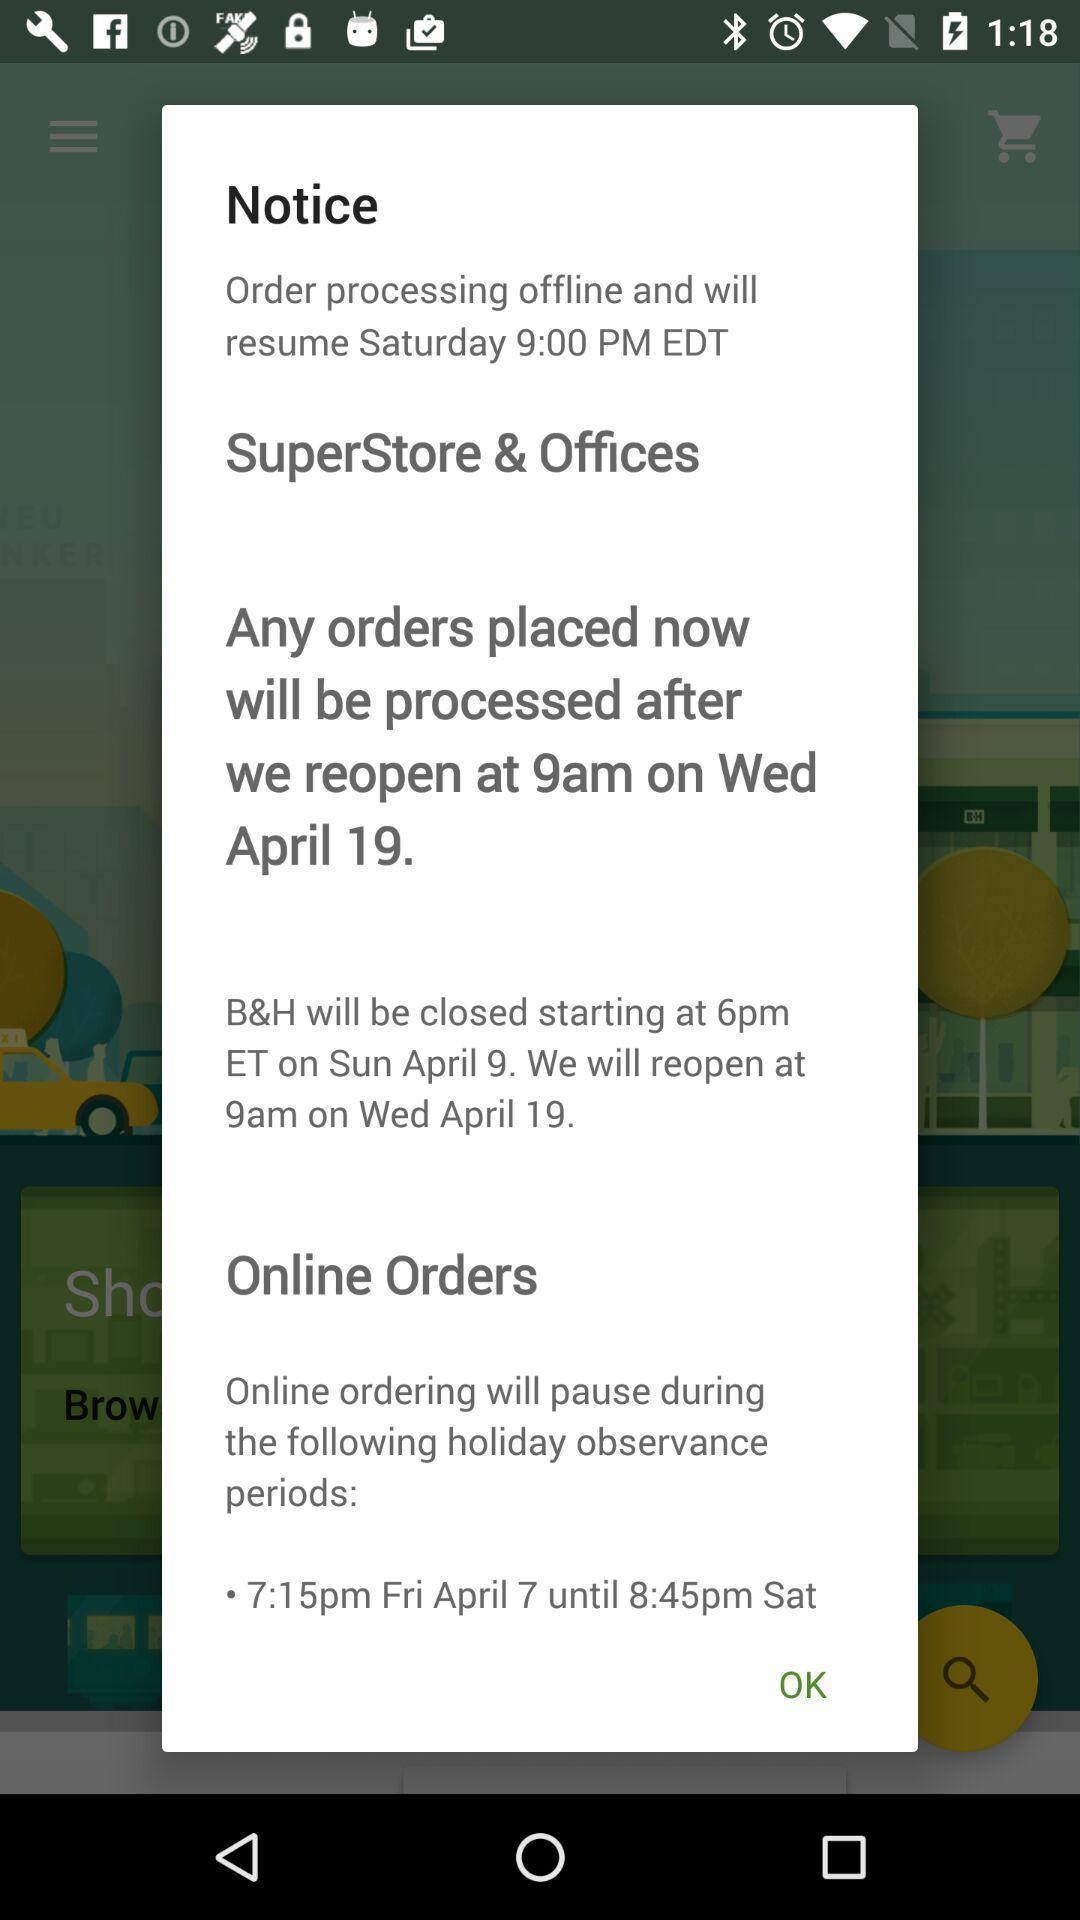Describe this image in words. Pop-up showing a notice for online orders. 